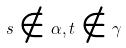<formula> <loc_0><loc_0><loc_500><loc_500>s \notin \alpha , t \notin \gamma</formula> 